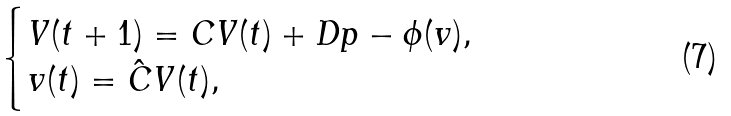<formula> <loc_0><loc_0><loc_500><loc_500>\begin{cases} V ( t + 1 ) = C V ( t ) + D p - \phi ( v ) , \\ v ( t ) = \hat { C } V ( t ) , \end{cases}</formula> 